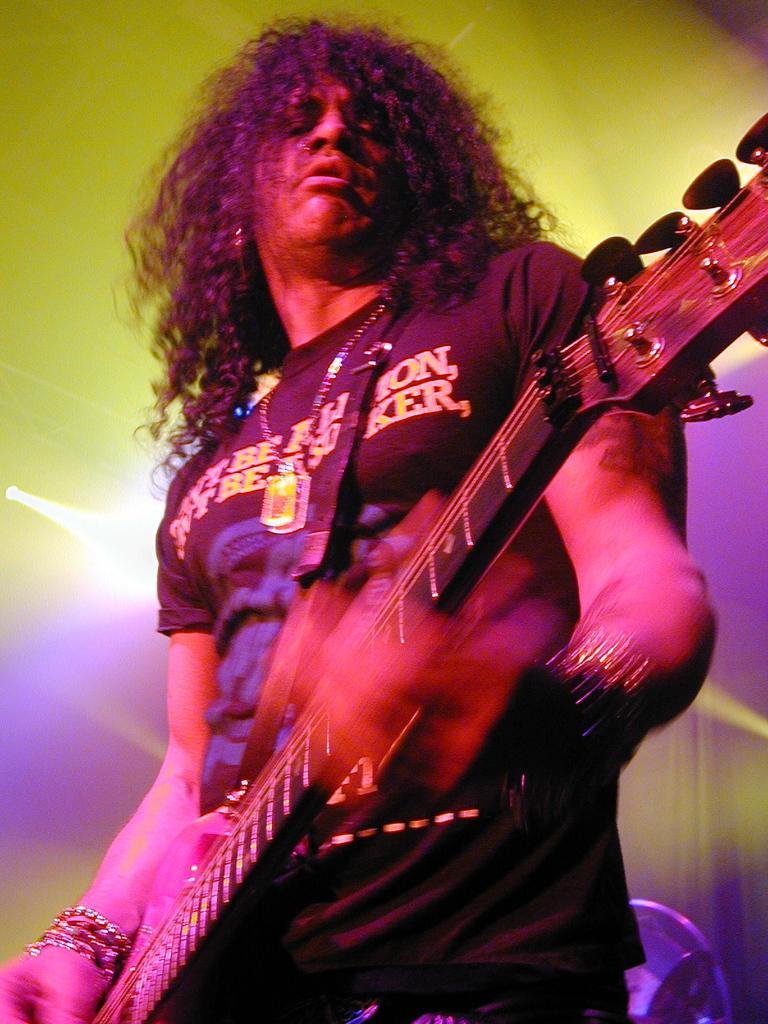Describe this image in one or two sentences. A man is playing guitar ,his hair is small and curly. He is wearing t shirt and trouser. he is wearing an ornament. 